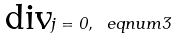<formula> <loc_0><loc_0><loc_500><loc_500>\text {div} { j } = 0 , \ e q n u m { 3 }</formula> 